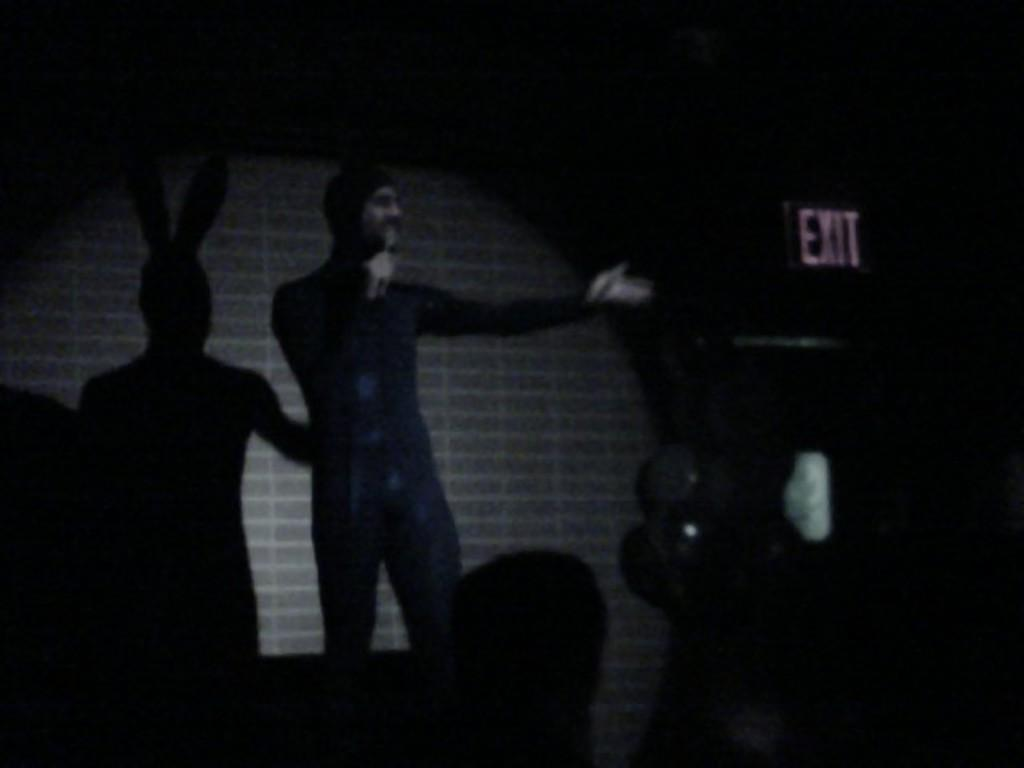What can be seen in the image? There is a person in the image. What is the person doing in the image? The person is holding an object. What is visible in the background of the image? There is a wall visible in the image. What else can be observed in the image? A shadow is present in the image, and there is a board with text on the right side of the image. How many apples are on the scene in the image? There are no apples present in the image. What type of coat is the person wearing in the image? The person in the image is not wearing a coat; they are holding an object. 